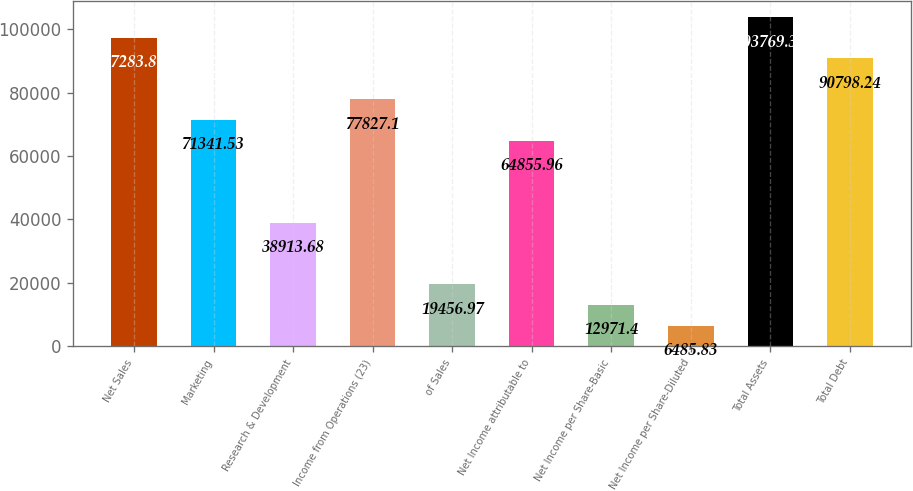Convert chart. <chart><loc_0><loc_0><loc_500><loc_500><bar_chart><fcel>Net Sales<fcel>Marketing<fcel>Research & Development<fcel>Income from Operations (23)<fcel>of Sales<fcel>Net Income attributable to<fcel>Net Income per Share-Basic<fcel>Net Income per Share-Diluted<fcel>Total Assets<fcel>Total Debt<nl><fcel>97283.8<fcel>71341.5<fcel>38913.7<fcel>77827.1<fcel>19457<fcel>64856<fcel>12971.4<fcel>6485.83<fcel>103769<fcel>90798.2<nl></chart> 